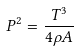<formula> <loc_0><loc_0><loc_500><loc_500>P ^ { 2 } = \frac { T ^ { 3 } } { 4 \rho A }</formula> 